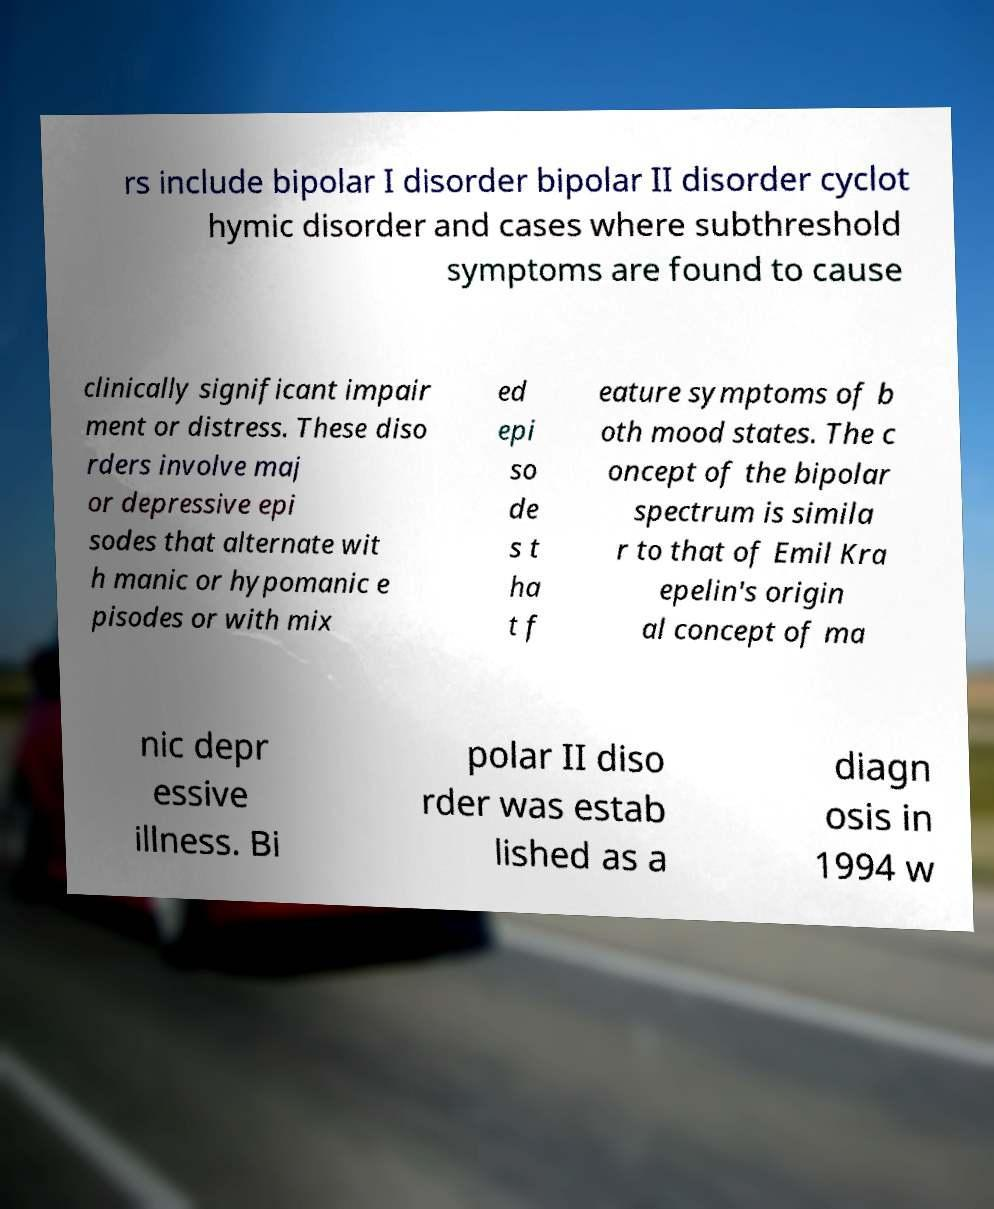I need the written content from this picture converted into text. Can you do that? rs include bipolar I disorder bipolar II disorder cyclot hymic disorder and cases where subthreshold symptoms are found to cause clinically significant impair ment or distress. These diso rders involve maj or depressive epi sodes that alternate wit h manic or hypomanic e pisodes or with mix ed epi so de s t ha t f eature symptoms of b oth mood states. The c oncept of the bipolar spectrum is simila r to that of Emil Kra epelin's origin al concept of ma nic depr essive illness. Bi polar II diso rder was estab lished as a diagn osis in 1994 w 